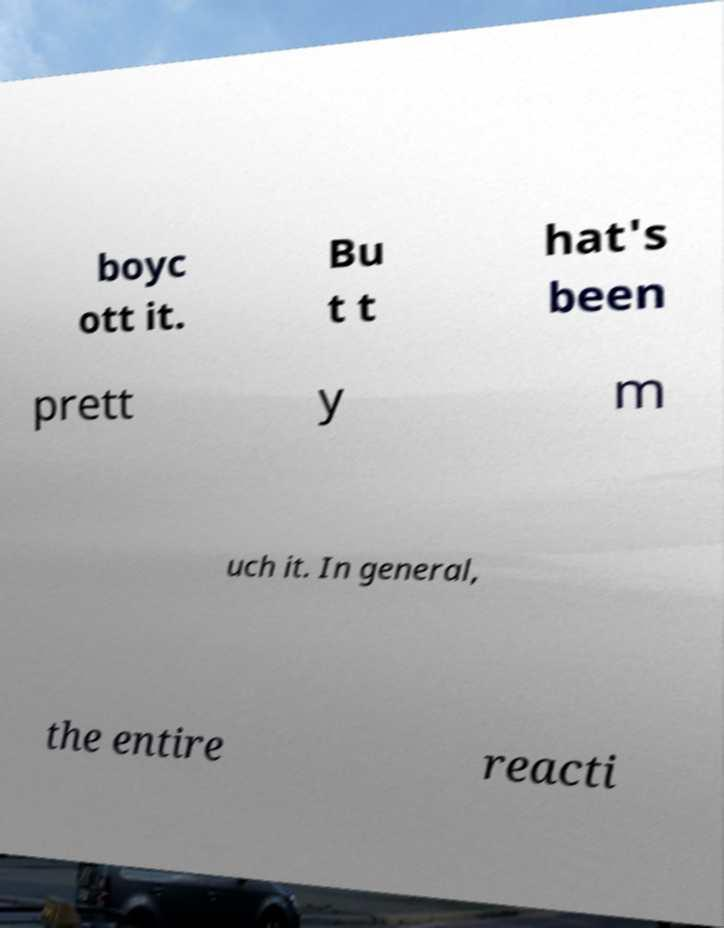Could you assist in decoding the text presented in this image and type it out clearly? boyc ott it. Bu t t hat's been prett y m uch it. In general, the entire reacti 